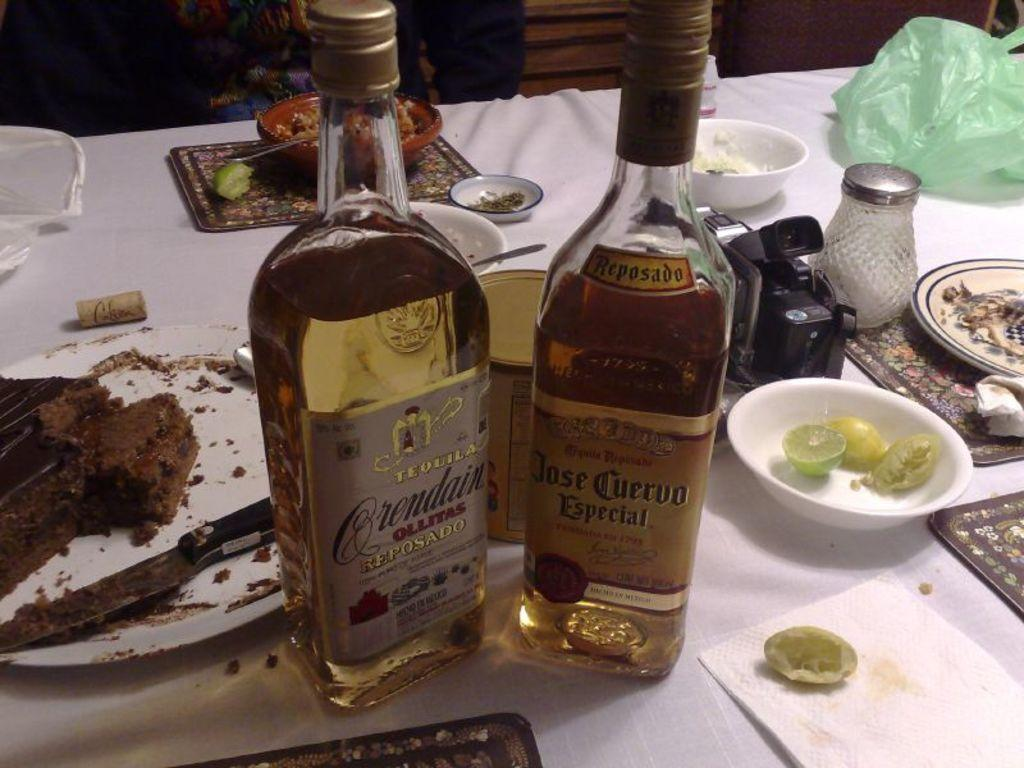<image>
Describe the image concisely. Two bottles of tequila sir on a white tablecloth next to half eaten cake. 